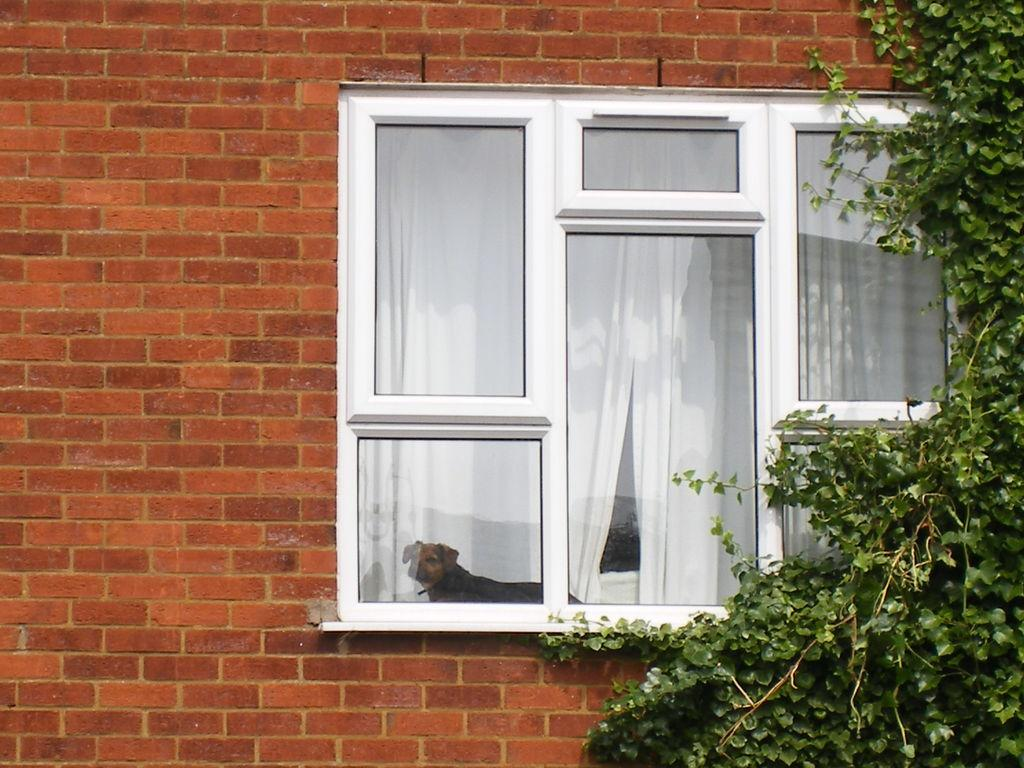What type of opening can be seen in the image? There is a window in the image. What type of structure is visible in the image? There is a brick wall in the image. What type of vegetation is present in the image? There is a plant in the image. What type of animal can be seen behind the window? There is a dog visible behind the window. What type of self-portrait is visible in the image? There is no self-portrait present in the image. How many snakes can be seen slithering around the plant in the image? There are no snakes present in the image; only a plant is visible. 